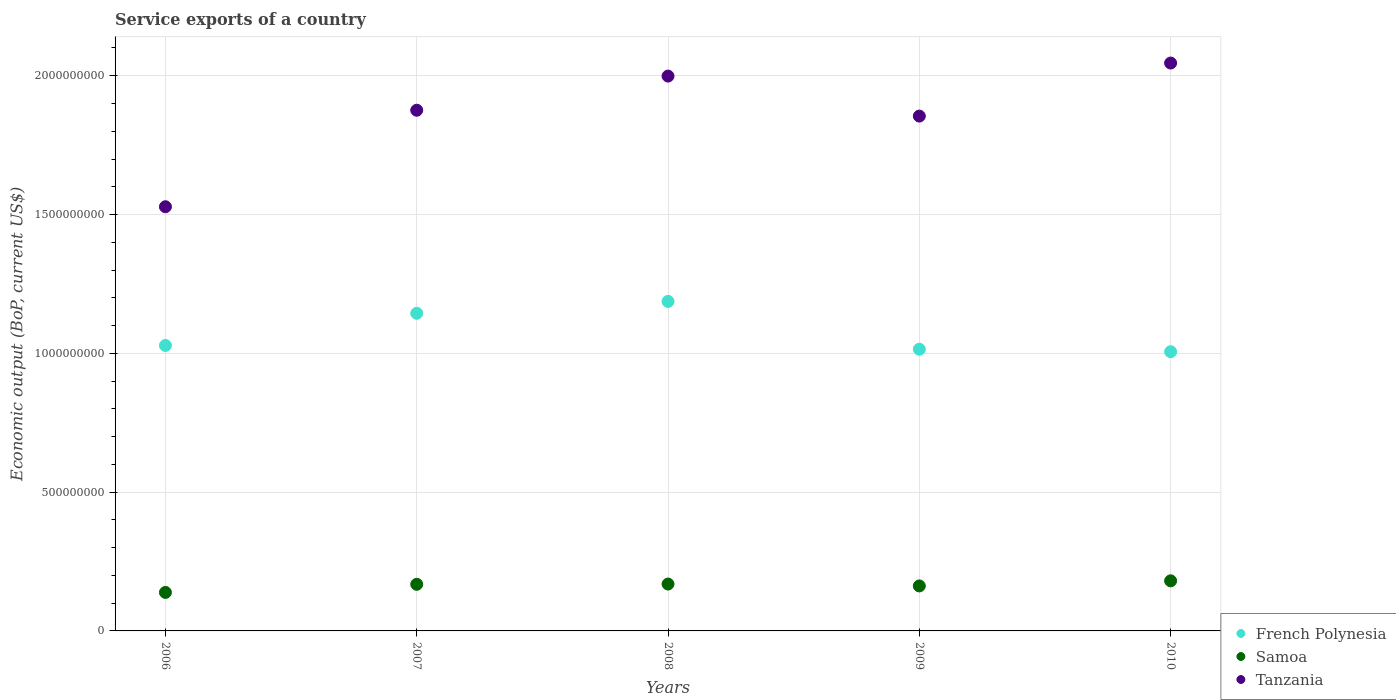Is the number of dotlines equal to the number of legend labels?
Your answer should be very brief. Yes. What is the service exports in Tanzania in 2009?
Ensure brevity in your answer.  1.85e+09. Across all years, what is the maximum service exports in French Polynesia?
Offer a very short reply. 1.19e+09. Across all years, what is the minimum service exports in French Polynesia?
Keep it short and to the point. 1.01e+09. What is the total service exports in Tanzania in the graph?
Provide a short and direct response. 9.30e+09. What is the difference between the service exports in Samoa in 2007 and that in 2008?
Offer a terse response. -9.72e+05. What is the difference between the service exports in Tanzania in 2006 and the service exports in French Polynesia in 2010?
Offer a terse response. 5.22e+08. What is the average service exports in Tanzania per year?
Give a very brief answer. 1.86e+09. In the year 2007, what is the difference between the service exports in Tanzania and service exports in Samoa?
Offer a very short reply. 1.71e+09. In how many years, is the service exports in French Polynesia greater than 1700000000 US$?
Provide a short and direct response. 0. What is the ratio of the service exports in French Polynesia in 2007 to that in 2010?
Offer a terse response. 1.14. Is the service exports in Tanzania in 2007 less than that in 2010?
Give a very brief answer. Yes. What is the difference between the highest and the second highest service exports in French Polynesia?
Your answer should be compact. 4.28e+07. What is the difference between the highest and the lowest service exports in French Polynesia?
Ensure brevity in your answer.  1.81e+08. In how many years, is the service exports in Samoa greater than the average service exports in Samoa taken over all years?
Provide a short and direct response. 3. Is it the case that in every year, the sum of the service exports in French Polynesia and service exports in Tanzania  is greater than the service exports in Samoa?
Your response must be concise. Yes. Does the service exports in Tanzania monotonically increase over the years?
Give a very brief answer. No. Is the service exports in French Polynesia strictly greater than the service exports in Tanzania over the years?
Make the answer very short. No. How many dotlines are there?
Give a very brief answer. 3. What is the difference between two consecutive major ticks on the Y-axis?
Provide a succinct answer. 5.00e+08. How many legend labels are there?
Your answer should be very brief. 3. How are the legend labels stacked?
Provide a succinct answer. Vertical. What is the title of the graph?
Make the answer very short. Service exports of a country. What is the label or title of the X-axis?
Your answer should be very brief. Years. What is the label or title of the Y-axis?
Offer a terse response. Economic output (BoP, current US$). What is the Economic output (BoP, current US$) in French Polynesia in 2006?
Ensure brevity in your answer.  1.03e+09. What is the Economic output (BoP, current US$) in Samoa in 2006?
Your response must be concise. 1.39e+08. What is the Economic output (BoP, current US$) in Tanzania in 2006?
Your response must be concise. 1.53e+09. What is the Economic output (BoP, current US$) in French Polynesia in 2007?
Offer a very short reply. 1.14e+09. What is the Economic output (BoP, current US$) of Samoa in 2007?
Offer a very short reply. 1.68e+08. What is the Economic output (BoP, current US$) in Tanzania in 2007?
Your response must be concise. 1.88e+09. What is the Economic output (BoP, current US$) of French Polynesia in 2008?
Provide a succinct answer. 1.19e+09. What is the Economic output (BoP, current US$) in Samoa in 2008?
Your response must be concise. 1.69e+08. What is the Economic output (BoP, current US$) of Tanzania in 2008?
Give a very brief answer. 2.00e+09. What is the Economic output (BoP, current US$) of French Polynesia in 2009?
Your response must be concise. 1.01e+09. What is the Economic output (BoP, current US$) of Samoa in 2009?
Offer a terse response. 1.62e+08. What is the Economic output (BoP, current US$) of Tanzania in 2009?
Your answer should be very brief. 1.85e+09. What is the Economic output (BoP, current US$) of French Polynesia in 2010?
Make the answer very short. 1.01e+09. What is the Economic output (BoP, current US$) in Samoa in 2010?
Your response must be concise. 1.80e+08. What is the Economic output (BoP, current US$) of Tanzania in 2010?
Keep it short and to the point. 2.05e+09. Across all years, what is the maximum Economic output (BoP, current US$) in French Polynesia?
Offer a terse response. 1.19e+09. Across all years, what is the maximum Economic output (BoP, current US$) in Samoa?
Offer a very short reply. 1.80e+08. Across all years, what is the maximum Economic output (BoP, current US$) of Tanzania?
Give a very brief answer. 2.05e+09. Across all years, what is the minimum Economic output (BoP, current US$) in French Polynesia?
Make the answer very short. 1.01e+09. Across all years, what is the minimum Economic output (BoP, current US$) in Samoa?
Your answer should be very brief. 1.39e+08. Across all years, what is the minimum Economic output (BoP, current US$) in Tanzania?
Provide a short and direct response. 1.53e+09. What is the total Economic output (BoP, current US$) of French Polynesia in the graph?
Keep it short and to the point. 5.38e+09. What is the total Economic output (BoP, current US$) in Samoa in the graph?
Make the answer very short. 8.18e+08. What is the total Economic output (BoP, current US$) of Tanzania in the graph?
Give a very brief answer. 9.30e+09. What is the difference between the Economic output (BoP, current US$) in French Polynesia in 2006 and that in 2007?
Your answer should be compact. -1.16e+08. What is the difference between the Economic output (BoP, current US$) of Samoa in 2006 and that in 2007?
Your answer should be very brief. -2.92e+07. What is the difference between the Economic output (BoP, current US$) of Tanzania in 2006 and that in 2007?
Give a very brief answer. -3.48e+08. What is the difference between the Economic output (BoP, current US$) in French Polynesia in 2006 and that in 2008?
Your response must be concise. -1.59e+08. What is the difference between the Economic output (BoP, current US$) of Samoa in 2006 and that in 2008?
Provide a succinct answer. -3.02e+07. What is the difference between the Economic output (BoP, current US$) of Tanzania in 2006 and that in 2008?
Offer a terse response. -4.71e+08. What is the difference between the Economic output (BoP, current US$) of French Polynesia in 2006 and that in 2009?
Provide a succinct answer. 1.36e+07. What is the difference between the Economic output (BoP, current US$) of Samoa in 2006 and that in 2009?
Give a very brief answer. -2.33e+07. What is the difference between the Economic output (BoP, current US$) of Tanzania in 2006 and that in 2009?
Your answer should be compact. -3.27e+08. What is the difference between the Economic output (BoP, current US$) in French Polynesia in 2006 and that in 2010?
Give a very brief answer. 2.26e+07. What is the difference between the Economic output (BoP, current US$) in Samoa in 2006 and that in 2010?
Your answer should be very brief. -4.18e+07. What is the difference between the Economic output (BoP, current US$) of Tanzania in 2006 and that in 2010?
Your answer should be compact. -5.18e+08. What is the difference between the Economic output (BoP, current US$) in French Polynesia in 2007 and that in 2008?
Your response must be concise. -4.28e+07. What is the difference between the Economic output (BoP, current US$) in Samoa in 2007 and that in 2008?
Offer a very short reply. -9.72e+05. What is the difference between the Economic output (BoP, current US$) of Tanzania in 2007 and that in 2008?
Offer a very short reply. -1.23e+08. What is the difference between the Economic output (BoP, current US$) in French Polynesia in 2007 and that in 2009?
Offer a very short reply. 1.29e+08. What is the difference between the Economic output (BoP, current US$) in Samoa in 2007 and that in 2009?
Offer a very short reply. 5.85e+06. What is the difference between the Economic output (BoP, current US$) in Tanzania in 2007 and that in 2009?
Keep it short and to the point. 2.11e+07. What is the difference between the Economic output (BoP, current US$) in French Polynesia in 2007 and that in 2010?
Offer a very short reply. 1.38e+08. What is the difference between the Economic output (BoP, current US$) of Samoa in 2007 and that in 2010?
Your answer should be compact. -1.26e+07. What is the difference between the Economic output (BoP, current US$) in Tanzania in 2007 and that in 2010?
Ensure brevity in your answer.  -1.70e+08. What is the difference between the Economic output (BoP, current US$) in French Polynesia in 2008 and that in 2009?
Provide a succinct answer. 1.72e+08. What is the difference between the Economic output (BoP, current US$) of Samoa in 2008 and that in 2009?
Provide a short and direct response. 6.82e+06. What is the difference between the Economic output (BoP, current US$) in Tanzania in 2008 and that in 2009?
Ensure brevity in your answer.  1.44e+08. What is the difference between the Economic output (BoP, current US$) in French Polynesia in 2008 and that in 2010?
Provide a succinct answer. 1.81e+08. What is the difference between the Economic output (BoP, current US$) in Samoa in 2008 and that in 2010?
Your response must be concise. -1.16e+07. What is the difference between the Economic output (BoP, current US$) of Tanzania in 2008 and that in 2010?
Offer a very short reply. -4.70e+07. What is the difference between the Economic output (BoP, current US$) in French Polynesia in 2009 and that in 2010?
Ensure brevity in your answer.  8.99e+06. What is the difference between the Economic output (BoP, current US$) of Samoa in 2009 and that in 2010?
Offer a very short reply. -1.84e+07. What is the difference between the Economic output (BoP, current US$) of Tanzania in 2009 and that in 2010?
Provide a short and direct response. -1.91e+08. What is the difference between the Economic output (BoP, current US$) of French Polynesia in 2006 and the Economic output (BoP, current US$) of Samoa in 2007?
Keep it short and to the point. 8.60e+08. What is the difference between the Economic output (BoP, current US$) in French Polynesia in 2006 and the Economic output (BoP, current US$) in Tanzania in 2007?
Provide a short and direct response. -8.47e+08. What is the difference between the Economic output (BoP, current US$) of Samoa in 2006 and the Economic output (BoP, current US$) of Tanzania in 2007?
Provide a succinct answer. -1.74e+09. What is the difference between the Economic output (BoP, current US$) in French Polynesia in 2006 and the Economic output (BoP, current US$) in Samoa in 2008?
Your response must be concise. 8.59e+08. What is the difference between the Economic output (BoP, current US$) of French Polynesia in 2006 and the Economic output (BoP, current US$) of Tanzania in 2008?
Your response must be concise. -9.70e+08. What is the difference between the Economic output (BoP, current US$) of Samoa in 2006 and the Economic output (BoP, current US$) of Tanzania in 2008?
Your answer should be very brief. -1.86e+09. What is the difference between the Economic output (BoP, current US$) in French Polynesia in 2006 and the Economic output (BoP, current US$) in Samoa in 2009?
Provide a short and direct response. 8.66e+08. What is the difference between the Economic output (BoP, current US$) of French Polynesia in 2006 and the Economic output (BoP, current US$) of Tanzania in 2009?
Keep it short and to the point. -8.26e+08. What is the difference between the Economic output (BoP, current US$) in Samoa in 2006 and the Economic output (BoP, current US$) in Tanzania in 2009?
Your answer should be very brief. -1.72e+09. What is the difference between the Economic output (BoP, current US$) in French Polynesia in 2006 and the Economic output (BoP, current US$) in Samoa in 2010?
Offer a terse response. 8.48e+08. What is the difference between the Economic output (BoP, current US$) of French Polynesia in 2006 and the Economic output (BoP, current US$) of Tanzania in 2010?
Keep it short and to the point. -1.02e+09. What is the difference between the Economic output (BoP, current US$) of Samoa in 2006 and the Economic output (BoP, current US$) of Tanzania in 2010?
Provide a succinct answer. -1.91e+09. What is the difference between the Economic output (BoP, current US$) in French Polynesia in 2007 and the Economic output (BoP, current US$) in Samoa in 2008?
Give a very brief answer. 9.75e+08. What is the difference between the Economic output (BoP, current US$) in French Polynesia in 2007 and the Economic output (BoP, current US$) in Tanzania in 2008?
Offer a terse response. -8.55e+08. What is the difference between the Economic output (BoP, current US$) in Samoa in 2007 and the Economic output (BoP, current US$) in Tanzania in 2008?
Give a very brief answer. -1.83e+09. What is the difference between the Economic output (BoP, current US$) in French Polynesia in 2007 and the Economic output (BoP, current US$) in Samoa in 2009?
Your answer should be compact. 9.82e+08. What is the difference between the Economic output (BoP, current US$) of French Polynesia in 2007 and the Economic output (BoP, current US$) of Tanzania in 2009?
Keep it short and to the point. -7.10e+08. What is the difference between the Economic output (BoP, current US$) in Samoa in 2007 and the Economic output (BoP, current US$) in Tanzania in 2009?
Your response must be concise. -1.69e+09. What is the difference between the Economic output (BoP, current US$) of French Polynesia in 2007 and the Economic output (BoP, current US$) of Samoa in 2010?
Your answer should be compact. 9.64e+08. What is the difference between the Economic output (BoP, current US$) of French Polynesia in 2007 and the Economic output (BoP, current US$) of Tanzania in 2010?
Keep it short and to the point. -9.02e+08. What is the difference between the Economic output (BoP, current US$) of Samoa in 2007 and the Economic output (BoP, current US$) of Tanzania in 2010?
Provide a succinct answer. -1.88e+09. What is the difference between the Economic output (BoP, current US$) of French Polynesia in 2008 and the Economic output (BoP, current US$) of Samoa in 2009?
Offer a terse response. 1.03e+09. What is the difference between the Economic output (BoP, current US$) of French Polynesia in 2008 and the Economic output (BoP, current US$) of Tanzania in 2009?
Your answer should be compact. -6.68e+08. What is the difference between the Economic output (BoP, current US$) in Samoa in 2008 and the Economic output (BoP, current US$) in Tanzania in 2009?
Your answer should be compact. -1.69e+09. What is the difference between the Economic output (BoP, current US$) in French Polynesia in 2008 and the Economic output (BoP, current US$) in Samoa in 2010?
Make the answer very short. 1.01e+09. What is the difference between the Economic output (BoP, current US$) in French Polynesia in 2008 and the Economic output (BoP, current US$) in Tanzania in 2010?
Ensure brevity in your answer.  -8.59e+08. What is the difference between the Economic output (BoP, current US$) of Samoa in 2008 and the Economic output (BoP, current US$) of Tanzania in 2010?
Offer a very short reply. -1.88e+09. What is the difference between the Economic output (BoP, current US$) in French Polynesia in 2009 and the Economic output (BoP, current US$) in Samoa in 2010?
Your answer should be compact. 8.34e+08. What is the difference between the Economic output (BoP, current US$) in French Polynesia in 2009 and the Economic output (BoP, current US$) in Tanzania in 2010?
Your answer should be very brief. -1.03e+09. What is the difference between the Economic output (BoP, current US$) of Samoa in 2009 and the Economic output (BoP, current US$) of Tanzania in 2010?
Ensure brevity in your answer.  -1.88e+09. What is the average Economic output (BoP, current US$) in French Polynesia per year?
Give a very brief answer. 1.08e+09. What is the average Economic output (BoP, current US$) in Samoa per year?
Your answer should be compact. 1.64e+08. What is the average Economic output (BoP, current US$) in Tanzania per year?
Your response must be concise. 1.86e+09. In the year 2006, what is the difference between the Economic output (BoP, current US$) in French Polynesia and Economic output (BoP, current US$) in Samoa?
Keep it short and to the point. 8.90e+08. In the year 2006, what is the difference between the Economic output (BoP, current US$) in French Polynesia and Economic output (BoP, current US$) in Tanzania?
Offer a very short reply. -5.00e+08. In the year 2006, what is the difference between the Economic output (BoP, current US$) in Samoa and Economic output (BoP, current US$) in Tanzania?
Your answer should be very brief. -1.39e+09. In the year 2007, what is the difference between the Economic output (BoP, current US$) of French Polynesia and Economic output (BoP, current US$) of Samoa?
Provide a succinct answer. 9.76e+08. In the year 2007, what is the difference between the Economic output (BoP, current US$) in French Polynesia and Economic output (BoP, current US$) in Tanzania?
Give a very brief answer. -7.31e+08. In the year 2007, what is the difference between the Economic output (BoP, current US$) in Samoa and Economic output (BoP, current US$) in Tanzania?
Offer a terse response. -1.71e+09. In the year 2008, what is the difference between the Economic output (BoP, current US$) of French Polynesia and Economic output (BoP, current US$) of Samoa?
Keep it short and to the point. 1.02e+09. In the year 2008, what is the difference between the Economic output (BoP, current US$) in French Polynesia and Economic output (BoP, current US$) in Tanzania?
Ensure brevity in your answer.  -8.12e+08. In the year 2008, what is the difference between the Economic output (BoP, current US$) in Samoa and Economic output (BoP, current US$) in Tanzania?
Give a very brief answer. -1.83e+09. In the year 2009, what is the difference between the Economic output (BoP, current US$) of French Polynesia and Economic output (BoP, current US$) of Samoa?
Your answer should be very brief. 8.53e+08. In the year 2009, what is the difference between the Economic output (BoP, current US$) in French Polynesia and Economic output (BoP, current US$) in Tanzania?
Keep it short and to the point. -8.40e+08. In the year 2009, what is the difference between the Economic output (BoP, current US$) of Samoa and Economic output (BoP, current US$) of Tanzania?
Your answer should be compact. -1.69e+09. In the year 2010, what is the difference between the Economic output (BoP, current US$) of French Polynesia and Economic output (BoP, current US$) of Samoa?
Ensure brevity in your answer.  8.25e+08. In the year 2010, what is the difference between the Economic output (BoP, current US$) in French Polynesia and Economic output (BoP, current US$) in Tanzania?
Make the answer very short. -1.04e+09. In the year 2010, what is the difference between the Economic output (BoP, current US$) of Samoa and Economic output (BoP, current US$) of Tanzania?
Provide a short and direct response. -1.87e+09. What is the ratio of the Economic output (BoP, current US$) in French Polynesia in 2006 to that in 2007?
Your answer should be very brief. 0.9. What is the ratio of the Economic output (BoP, current US$) in Samoa in 2006 to that in 2007?
Your answer should be very brief. 0.83. What is the ratio of the Economic output (BoP, current US$) in Tanzania in 2006 to that in 2007?
Your response must be concise. 0.81. What is the ratio of the Economic output (BoP, current US$) in French Polynesia in 2006 to that in 2008?
Give a very brief answer. 0.87. What is the ratio of the Economic output (BoP, current US$) of Samoa in 2006 to that in 2008?
Make the answer very short. 0.82. What is the ratio of the Economic output (BoP, current US$) in Tanzania in 2006 to that in 2008?
Your response must be concise. 0.76. What is the ratio of the Economic output (BoP, current US$) of French Polynesia in 2006 to that in 2009?
Offer a very short reply. 1.01. What is the ratio of the Economic output (BoP, current US$) of Samoa in 2006 to that in 2009?
Provide a short and direct response. 0.86. What is the ratio of the Economic output (BoP, current US$) in Tanzania in 2006 to that in 2009?
Your answer should be very brief. 0.82. What is the ratio of the Economic output (BoP, current US$) in French Polynesia in 2006 to that in 2010?
Provide a short and direct response. 1.02. What is the ratio of the Economic output (BoP, current US$) of Samoa in 2006 to that in 2010?
Offer a terse response. 0.77. What is the ratio of the Economic output (BoP, current US$) in Tanzania in 2006 to that in 2010?
Your answer should be very brief. 0.75. What is the ratio of the Economic output (BoP, current US$) of French Polynesia in 2007 to that in 2008?
Offer a very short reply. 0.96. What is the ratio of the Economic output (BoP, current US$) of Samoa in 2007 to that in 2008?
Make the answer very short. 0.99. What is the ratio of the Economic output (BoP, current US$) in Tanzania in 2007 to that in 2008?
Your answer should be very brief. 0.94. What is the ratio of the Economic output (BoP, current US$) in French Polynesia in 2007 to that in 2009?
Provide a short and direct response. 1.13. What is the ratio of the Economic output (BoP, current US$) of Samoa in 2007 to that in 2009?
Offer a terse response. 1.04. What is the ratio of the Economic output (BoP, current US$) in Tanzania in 2007 to that in 2009?
Offer a very short reply. 1.01. What is the ratio of the Economic output (BoP, current US$) of French Polynesia in 2007 to that in 2010?
Your answer should be very brief. 1.14. What is the ratio of the Economic output (BoP, current US$) of Samoa in 2007 to that in 2010?
Provide a succinct answer. 0.93. What is the ratio of the Economic output (BoP, current US$) in Tanzania in 2007 to that in 2010?
Provide a succinct answer. 0.92. What is the ratio of the Economic output (BoP, current US$) of French Polynesia in 2008 to that in 2009?
Provide a succinct answer. 1.17. What is the ratio of the Economic output (BoP, current US$) of Samoa in 2008 to that in 2009?
Your answer should be very brief. 1.04. What is the ratio of the Economic output (BoP, current US$) in Tanzania in 2008 to that in 2009?
Your answer should be very brief. 1.08. What is the ratio of the Economic output (BoP, current US$) of French Polynesia in 2008 to that in 2010?
Provide a short and direct response. 1.18. What is the ratio of the Economic output (BoP, current US$) in Samoa in 2008 to that in 2010?
Make the answer very short. 0.94. What is the ratio of the Economic output (BoP, current US$) in Tanzania in 2008 to that in 2010?
Ensure brevity in your answer.  0.98. What is the ratio of the Economic output (BoP, current US$) of French Polynesia in 2009 to that in 2010?
Provide a short and direct response. 1.01. What is the ratio of the Economic output (BoP, current US$) of Samoa in 2009 to that in 2010?
Ensure brevity in your answer.  0.9. What is the ratio of the Economic output (BoP, current US$) in Tanzania in 2009 to that in 2010?
Offer a very short reply. 0.91. What is the difference between the highest and the second highest Economic output (BoP, current US$) of French Polynesia?
Offer a very short reply. 4.28e+07. What is the difference between the highest and the second highest Economic output (BoP, current US$) of Samoa?
Your response must be concise. 1.16e+07. What is the difference between the highest and the second highest Economic output (BoP, current US$) of Tanzania?
Make the answer very short. 4.70e+07. What is the difference between the highest and the lowest Economic output (BoP, current US$) of French Polynesia?
Offer a terse response. 1.81e+08. What is the difference between the highest and the lowest Economic output (BoP, current US$) in Samoa?
Make the answer very short. 4.18e+07. What is the difference between the highest and the lowest Economic output (BoP, current US$) of Tanzania?
Your answer should be compact. 5.18e+08. 